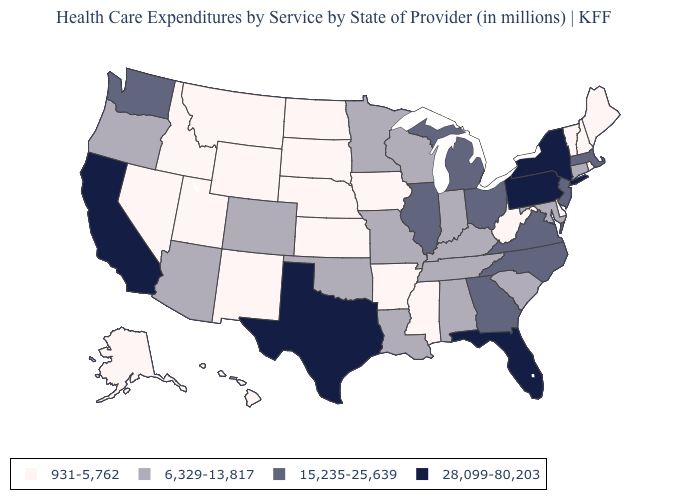Does Florida have the highest value in the South?
Concise answer only. Yes. What is the value of Oklahoma?
Give a very brief answer. 6,329-13,817. Does the map have missing data?
Short answer required. No. Does Nevada have the lowest value in the USA?
Quick response, please. Yes. What is the lowest value in states that border Kentucky?
Be succinct. 931-5,762. Name the states that have a value in the range 6,329-13,817?
Concise answer only. Alabama, Arizona, Colorado, Connecticut, Indiana, Kentucky, Louisiana, Maryland, Minnesota, Missouri, Oklahoma, Oregon, South Carolina, Tennessee, Wisconsin. Does New York have the highest value in the USA?
Quick response, please. Yes. Among the states that border Texas , does Arkansas have the highest value?
Give a very brief answer. No. Name the states that have a value in the range 28,099-80,203?
Be succinct. California, Florida, New York, Pennsylvania, Texas. Which states hav the highest value in the Northeast?
Quick response, please. New York, Pennsylvania. Name the states that have a value in the range 931-5,762?
Keep it brief. Alaska, Arkansas, Delaware, Hawaii, Idaho, Iowa, Kansas, Maine, Mississippi, Montana, Nebraska, Nevada, New Hampshire, New Mexico, North Dakota, Rhode Island, South Dakota, Utah, Vermont, West Virginia, Wyoming. Does Virginia have a lower value than California?
Be succinct. Yes. Is the legend a continuous bar?
Write a very short answer. No. What is the value of Ohio?
Be succinct. 15,235-25,639. Does Virginia have the same value as North Dakota?
Concise answer only. No. 